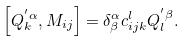Convert formula to latex. <formula><loc_0><loc_0><loc_500><loc_500>\left [ Q _ { k } ^ { ^ { \prime } \alpha } , M _ { i j } \right ] = \delta _ { \beta } ^ { \alpha } c _ { i j k } ^ { l } Q _ { l } ^ { ^ { \prime } \beta } .</formula> 